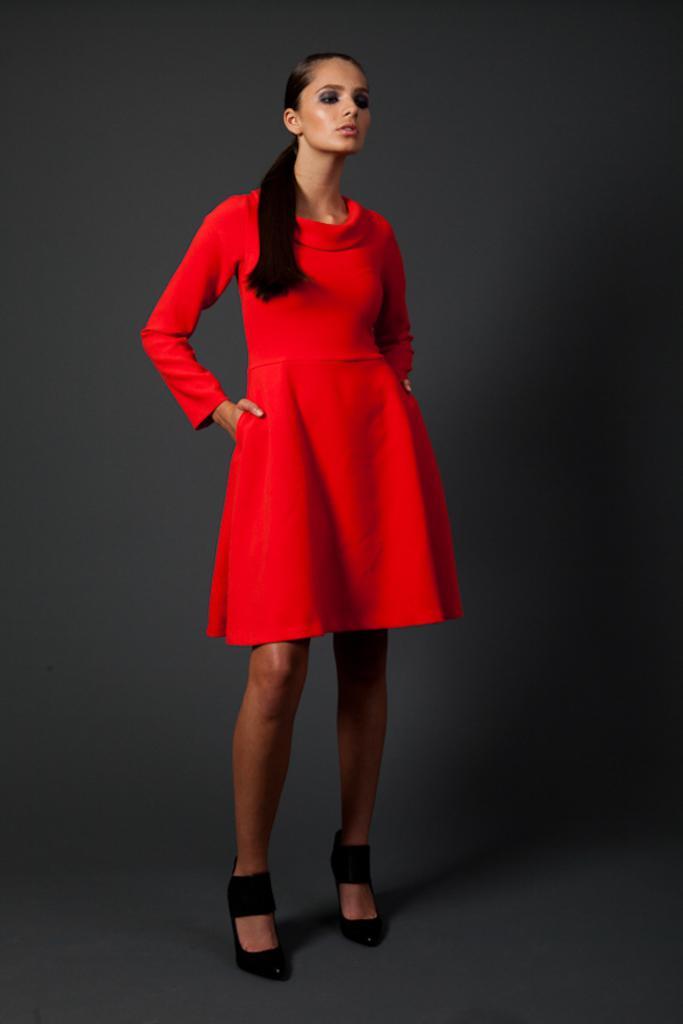In one or two sentences, can you explain what this image depicts? In the picture we can see a woman standing with a heels, which are black in color and she is wearing a red dress and keeping her hands on the hip. 